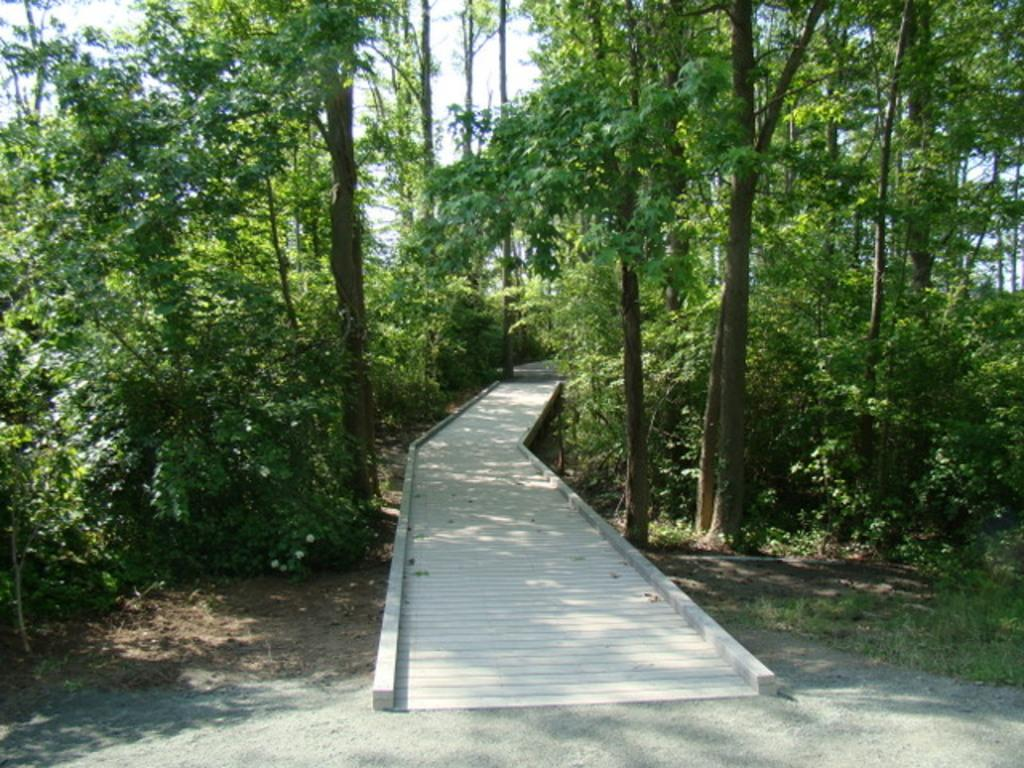What type of vegetation is predominant in the image? There are many trees in the image. What type of surface is visible in the image? There is a wooden street in the image. Where can grass be seen in the image? Grass is visible in the bottom right of the image. What is visible in the sky in the image? The sky is visible in the image, at the top, and clouds are present. Can you describe the wave that is crashing onto the wooden street in the image? There is no wave present in the image; it features a wooden street, trees, grass, and a sky with clouds. How does the zebra interact with the trees in the image? There is no zebra present in the image; it features a wooden street, trees, grass, and a sky with clouds. 